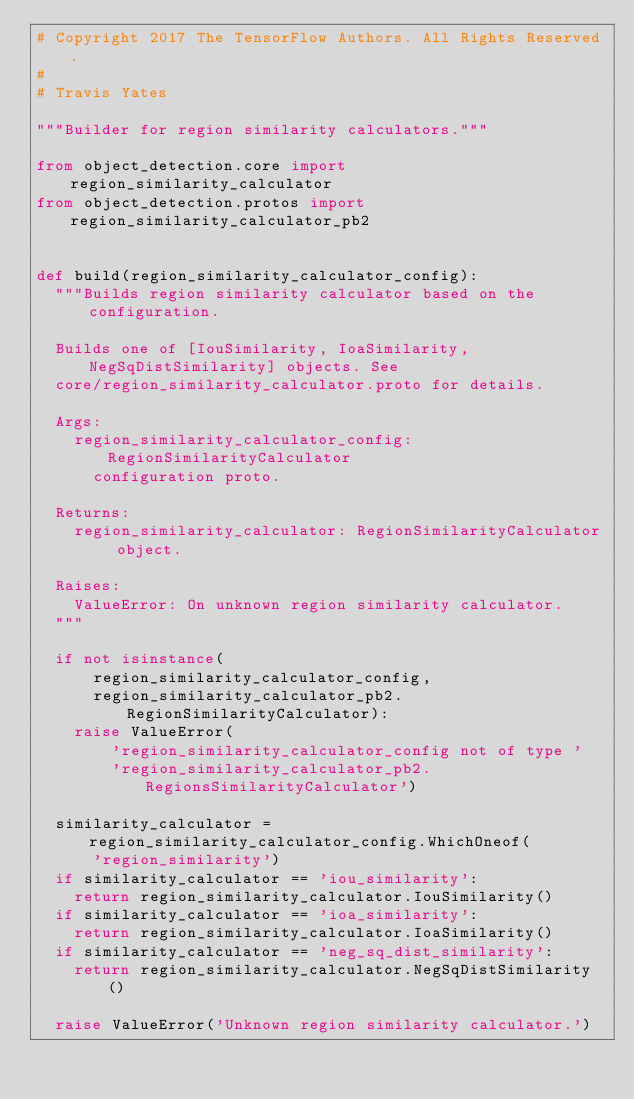Convert code to text. <code><loc_0><loc_0><loc_500><loc_500><_Python_># Copyright 2017 The TensorFlow Authors. All Rights Reserved.
#
# Travis Yates

"""Builder for region similarity calculators."""

from object_detection.core import region_similarity_calculator
from object_detection.protos import region_similarity_calculator_pb2


def build(region_similarity_calculator_config):
  """Builds region similarity calculator based on the configuration.

  Builds one of [IouSimilarity, IoaSimilarity, NegSqDistSimilarity] objects. See
  core/region_similarity_calculator.proto for details.

  Args:
    region_similarity_calculator_config: RegionSimilarityCalculator
      configuration proto.

  Returns:
    region_similarity_calculator: RegionSimilarityCalculator object.

  Raises:
    ValueError: On unknown region similarity calculator.
  """

  if not isinstance(
      region_similarity_calculator_config,
      region_similarity_calculator_pb2.RegionSimilarityCalculator):
    raise ValueError(
        'region_similarity_calculator_config not of type '
        'region_similarity_calculator_pb2.RegionsSimilarityCalculator')

  similarity_calculator = region_similarity_calculator_config.WhichOneof(
      'region_similarity')
  if similarity_calculator == 'iou_similarity':
    return region_similarity_calculator.IouSimilarity()
  if similarity_calculator == 'ioa_similarity':
    return region_similarity_calculator.IoaSimilarity()
  if similarity_calculator == 'neg_sq_dist_similarity':
    return region_similarity_calculator.NegSqDistSimilarity()

  raise ValueError('Unknown region similarity calculator.')

</code> 